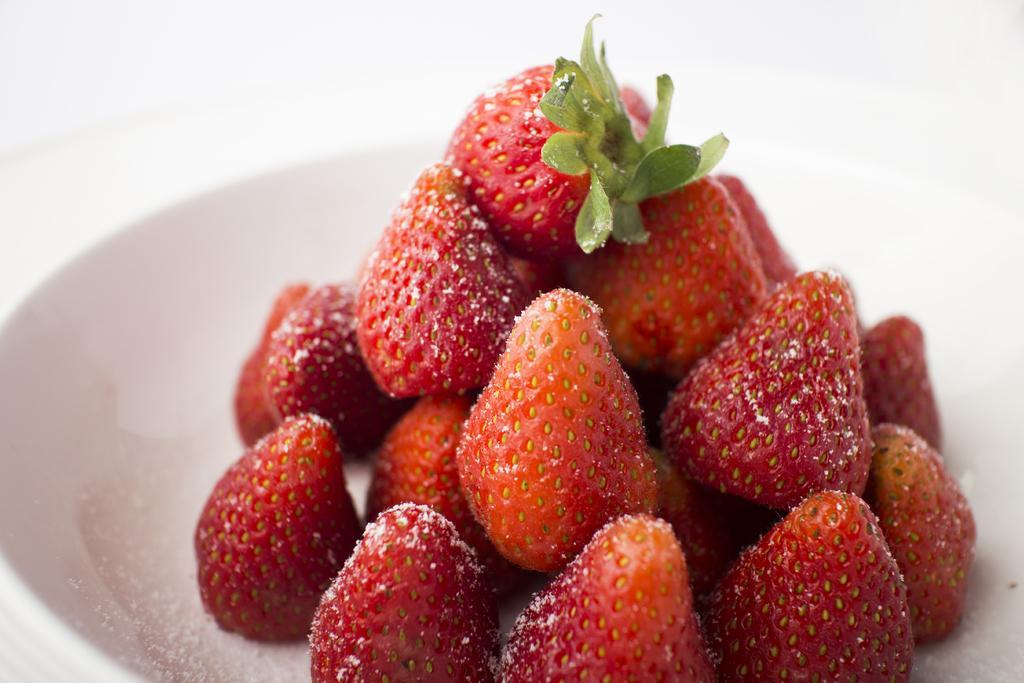How would you summarize this image in a sentence or two? Here in this picture we can see strawberries present in a bowl over there. 